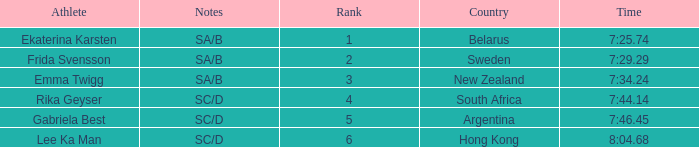What is the total rank for the athlete that had a race time of 7:34.24? 1.0. I'm looking to parse the entire table for insights. Could you assist me with that? {'header': ['Athlete', 'Notes', 'Rank', 'Country', 'Time'], 'rows': [['Ekaterina Karsten', 'SA/B', '1', 'Belarus', '7:25.74'], ['Frida Svensson', 'SA/B', '2', 'Sweden', '7:29.29'], ['Emma Twigg', 'SA/B', '3', 'New Zealand', '7:34.24'], ['Rika Geyser', 'SC/D', '4', 'South Africa', '7:44.14'], ['Gabriela Best', 'SC/D', '5', 'Argentina', '7:46.45'], ['Lee Ka Man', 'SC/D', '6', 'Hong Kong', '8:04.68']]} 